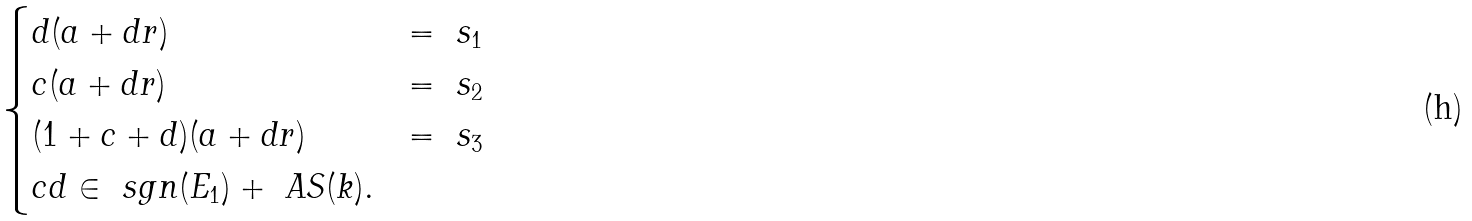<formula> <loc_0><loc_0><loc_500><loc_500>\begin{cases} d ( a + d r ) & = \ s _ { 1 } \\ c ( a + d r ) & = \ s _ { 2 } \\ ( 1 + c + d ) ( a + d r ) & = \ s _ { 3 } \\ c d \in \ s g n ( E _ { 1 } ) + \ A S ( k ) . & \end{cases}</formula> 